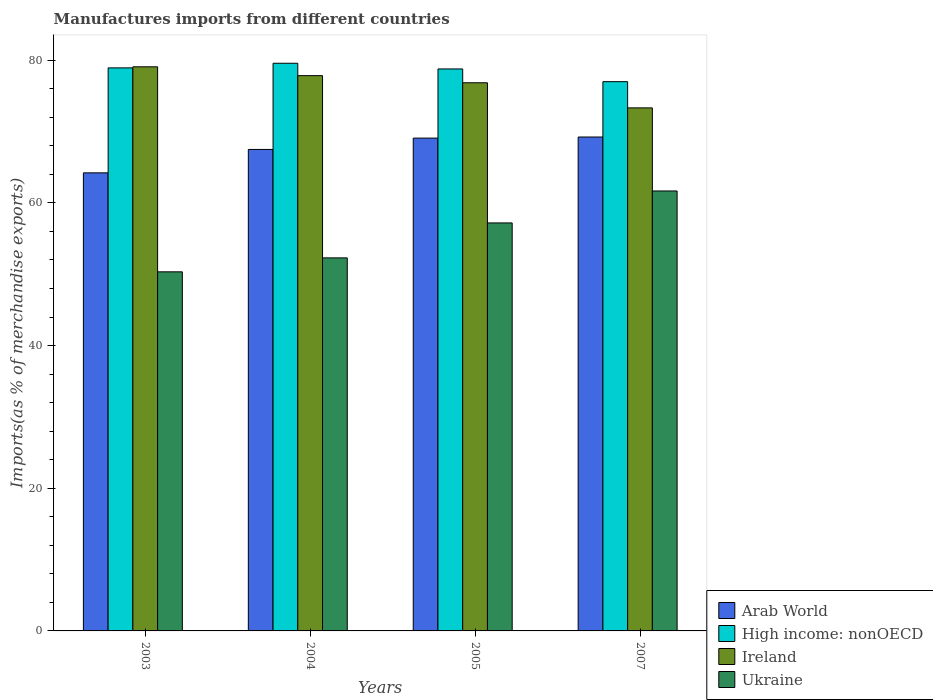How many groups of bars are there?
Your response must be concise. 4. How many bars are there on the 1st tick from the right?
Your response must be concise. 4. What is the label of the 4th group of bars from the left?
Offer a very short reply. 2007. What is the percentage of imports to different countries in High income: nonOECD in 2005?
Keep it short and to the point. 78.78. Across all years, what is the maximum percentage of imports to different countries in Ireland?
Your answer should be compact. 79.08. Across all years, what is the minimum percentage of imports to different countries in Ukraine?
Give a very brief answer. 50.34. What is the total percentage of imports to different countries in Ireland in the graph?
Offer a very short reply. 307.09. What is the difference between the percentage of imports to different countries in High income: nonOECD in 2003 and that in 2005?
Your answer should be compact. 0.15. What is the difference between the percentage of imports to different countries in Ukraine in 2005 and the percentage of imports to different countries in Ireland in 2003?
Provide a short and direct response. -21.89. What is the average percentage of imports to different countries in Ukraine per year?
Your answer should be very brief. 55.38. In the year 2004, what is the difference between the percentage of imports to different countries in Ukraine and percentage of imports to different countries in Ireland?
Offer a terse response. -25.55. In how many years, is the percentage of imports to different countries in Arab World greater than 52 %?
Make the answer very short. 4. What is the ratio of the percentage of imports to different countries in Arab World in 2003 to that in 2007?
Offer a terse response. 0.93. Is the percentage of imports to different countries in Ukraine in 2003 less than that in 2005?
Offer a terse response. Yes. What is the difference between the highest and the second highest percentage of imports to different countries in Arab World?
Your response must be concise. 0.15. What is the difference between the highest and the lowest percentage of imports to different countries in Arab World?
Ensure brevity in your answer.  5.03. In how many years, is the percentage of imports to different countries in Ireland greater than the average percentage of imports to different countries in Ireland taken over all years?
Give a very brief answer. 3. Is it the case that in every year, the sum of the percentage of imports to different countries in Ireland and percentage of imports to different countries in Arab World is greater than the sum of percentage of imports to different countries in Ukraine and percentage of imports to different countries in High income: nonOECD?
Provide a succinct answer. No. What does the 4th bar from the left in 2003 represents?
Give a very brief answer. Ukraine. What does the 1st bar from the right in 2003 represents?
Your response must be concise. Ukraine. Is it the case that in every year, the sum of the percentage of imports to different countries in High income: nonOECD and percentage of imports to different countries in Ireland is greater than the percentage of imports to different countries in Arab World?
Offer a terse response. Yes. How many bars are there?
Give a very brief answer. 16. Are all the bars in the graph horizontal?
Ensure brevity in your answer.  No. How many years are there in the graph?
Your answer should be very brief. 4. Where does the legend appear in the graph?
Your response must be concise. Bottom right. How many legend labels are there?
Provide a succinct answer. 4. What is the title of the graph?
Provide a succinct answer. Manufactures imports from different countries. What is the label or title of the Y-axis?
Offer a terse response. Imports(as % of merchandise exports). What is the Imports(as % of merchandise exports) of Arab World in 2003?
Your response must be concise. 64.22. What is the Imports(as % of merchandise exports) of High income: nonOECD in 2003?
Offer a very short reply. 78.93. What is the Imports(as % of merchandise exports) of Ireland in 2003?
Give a very brief answer. 79.08. What is the Imports(as % of merchandise exports) of Ukraine in 2003?
Your answer should be compact. 50.34. What is the Imports(as % of merchandise exports) of Arab World in 2004?
Offer a terse response. 67.5. What is the Imports(as % of merchandise exports) in High income: nonOECD in 2004?
Offer a very short reply. 79.58. What is the Imports(as % of merchandise exports) in Ireland in 2004?
Give a very brief answer. 77.84. What is the Imports(as % of merchandise exports) in Ukraine in 2004?
Provide a succinct answer. 52.3. What is the Imports(as % of merchandise exports) of Arab World in 2005?
Provide a short and direct response. 69.09. What is the Imports(as % of merchandise exports) of High income: nonOECD in 2005?
Keep it short and to the point. 78.78. What is the Imports(as % of merchandise exports) of Ireland in 2005?
Provide a succinct answer. 76.84. What is the Imports(as % of merchandise exports) of Ukraine in 2005?
Keep it short and to the point. 57.19. What is the Imports(as % of merchandise exports) in Arab World in 2007?
Keep it short and to the point. 69.24. What is the Imports(as % of merchandise exports) in High income: nonOECD in 2007?
Offer a very short reply. 77. What is the Imports(as % of merchandise exports) in Ireland in 2007?
Keep it short and to the point. 73.32. What is the Imports(as % of merchandise exports) in Ukraine in 2007?
Provide a short and direct response. 61.68. Across all years, what is the maximum Imports(as % of merchandise exports) in Arab World?
Your answer should be compact. 69.24. Across all years, what is the maximum Imports(as % of merchandise exports) in High income: nonOECD?
Give a very brief answer. 79.58. Across all years, what is the maximum Imports(as % of merchandise exports) of Ireland?
Your response must be concise. 79.08. Across all years, what is the maximum Imports(as % of merchandise exports) in Ukraine?
Give a very brief answer. 61.68. Across all years, what is the minimum Imports(as % of merchandise exports) of Arab World?
Keep it short and to the point. 64.22. Across all years, what is the minimum Imports(as % of merchandise exports) of High income: nonOECD?
Ensure brevity in your answer.  77. Across all years, what is the minimum Imports(as % of merchandise exports) of Ireland?
Offer a very short reply. 73.32. Across all years, what is the minimum Imports(as % of merchandise exports) of Ukraine?
Give a very brief answer. 50.34. What is the total Imports(as % of merchandise exports) of Arab World in the graph?
Keep it short and to the point. 270.04. What is the total Imports(as % of merchandise exports) in High income: nonOECD in the graph?
Your answer should be very brief. 314.29. What is the total Imports(as % of merchandise exports) of Ireland in the graph?
Offer a very short reply. 307.09. What is the total Imports(as % of merchandise exports) of Ukraine in the graph?
Make the answer very short. 221.51. What is the difference between the Imports(as % of merchandise exports) in Arab World in 2003 and that in 2004?
Your answer should be compact. -3.28. What is the difference between the Imports(as % of merchandise exports) of High income: nonOECD in 2003 and that in 2004?
Your answer should be compact. -0.65. What is the difference between the Imports(as % of merchandise exports) in Ireland in 2003 and that in 2004?
Keep it short and to the point. 1.24. What is the difference between the Imports(as % of merchandise exports) in Ukraine in 2003 and that in 2004?
Keep it short and to the point. -1.96. What is the difference between the Imports(as % of merchandise exports) in Arab World in 2003 and that in 2005?
Your answer should be compact. -4.87. What is the difference between the Imports(as % of merchandise exports) in High income: nonOECD in 2003 and that in 2005?
Your answer should be compact. 0.15. What is the difference between the Imports(as % of merchandise exports) in Ireland in 2003 and that in 2005?
Your answer should be compact. 2.24. What is the difference between the Imports(as % of merchandise exports) of Ukraine in 2003 and that in 2005?
Make the answer very short. -6.86. What is the difference between the Imports(as % of merchandise exports) of Arab World in 2003 and that in 2007?
Ensure brevity in your answer.  -5.03. What is the difference between the Imports(as % of merchandise exports) in High income: nonOECD in 2003 and that in 2007?
Your answer should be compact. 1.93. What is the difference between the Imports(as % of merchandise exports) in Ireland in 2003 and that in 2007?
Your answer should be compact. 5.76. What is the difference between the Imports(as % of merchandise exports) of Ukraine in 2003 and that in 2007?
Ensure brevity in your answer.  -11.34. What is the difference between the Imports(as % of merchandise exports) of Arab World in 2004 and that in 2005?
Your answer should be compact. -1.59. What is the difference between the Imports(as % of merchandise exports) in High income: nonOECD in 2004 and that in 2005?
Ensure brevity in your answer.  0.8. What is the difference between the Imports(as % of merchandise exports) in Ireland in 2004 and that in 2005?
Keep it short and to the point. 1. What is the difference between the Imports(as % of merchandise exports) in Ukraine in 2004 and that in 2005?
Ensure brevity in your answer.  -4.9. What is the difference between the Imports(as % of merchandise exports) in Arab World in 2004 and that in 2007?
Offer a very short reply. -1.74. What is the difference between the Imports(as % of merchandise exports) in High income: nonOECD in 2004 and that in 2007?
Provide a short and direct response. 2.58. What is the difference between the Imports(as % of merchandise exports) of Ireland in 2004 and that in 2007?
Offer a very short reply. 4.52. What is the difference between the Imports(as % of merchandise exports) in Ukraine in 2004 and that in 2007?
Ensure brevity in your answer.  -9.38. What is the difference between the Imports(as % of merchandise exports) in Arab World in 2005 and that in 2007?
Offer a terse response. -0.15. What is the difference between the Imports(as % of merchandise exports) in High income: nonOECD in 2005 and that in 2007?
Your response must be concise. 1.78. What is the difference between the Imports(as % of merchandise exports) in Ireland in 2005 and that in 2007?
Give a very brief answer. 3.52. What is the difference between the Imports(as % of merchandise exports) of Ukraine in 2005 and that in 2007?
Offer a terse response. -4.48. What is the difference between the Imports(as % of merchandise exports) in Arab World in 2003 and the Imports(as % of merchandise exports) in High income: nonOECD in 2004?
Your answer should be very brief. -15.36. What is the difference between the Imports(as % of merchandise exports) in Arab World in 2003 and the Imports(as % of merchandise exports) in Ireland in 2004?
Provide a succinct answer. -13.63. What is the difference between the Imports(as % of merchandise exports) of Arab World in 2003 and the Imports(as % of merchandise exports) of Ukraine in 2004?
Give a very brief answer. 11.92. What is the difference between the Imports(as % of merchandise exports) in High income: nonOECD in 2003 and the Imports(as % of merchandise exports) in Ireland in 2004?
Your answer should be very brief. 1.09. What is the difference between the Imports(as % of merchandise exports) of High income: nonOECD in 2003 and the Imports(as % of merchandise exports) of Ukraine in 2004?
Make the answer very short. 26.64. What is the difference between the Imports(as % of merchandise exports) of Ireland in 2003 and the Imports(as % of merchandise exports) of Ukraine in 2004?
Ensure brevity in your answer.  26.79. What is the difference between the Imports(as % of merchandise exports) in Arab World in 2003 and the Imports(as % of merchandise exports) in High income: nonOECD in 2005?
Your response must be concise. -14.57. What is the difference between the Imports(as % of merchandise exports) in Arab World in 2003 and the Imports(as % of merchandise exports) in Ireland in 2005?
Your answer should be compact. -12.63. What is the difference between the Imports(as % of merchandise exports) of Arab World in 2003 and the Imports(as % of merchandise exports) of Ukraine in 2005?
Your answer should be very brief. 7.02. What is the difference between the Imports(as % of merchandise exports) of High income: nonOECD in 2003 and the Imports(as % of merchandise exports) of Ireland in 2005?
Offer a very short reply. 2.09. What is the difference between the Imports(as % of merchandise exports) in High income: nonOECD in 2003 and the Imports(as % of merchandise exports) in Ukraine in 2005?
Give a very brief answer. 21.74. What is the difference between the Imports(as % of merchandise exports) in Ireland in 2003 and the Imports(as % of merchandise exports) in Ukraine in 2005?
Keep it short and to the point. 21.89. What is the difference between the Imports(as % of merchandise exports) of Arab World in 2003 and the Imports(as % of merchandise exports) of High income: nonOECD in 2007?
Give a very brief answer. -12.78. What is the difference between the Imports(as % of merchandise exports) of Arab World in 2003 and the Imports(as % of merchandise exports) of Ireland in 2007?
Your answer should be compact. -9.11. What is the difference between the Imports(as % of merchandise exports) in Arab World in 2003 and the Imports(as % of merchandise exports) in Ukraine in 2007?
Your answer should be very brief. 2.54. What is the difference between the Imports(as % of merchandise exports) in High income: nonOECD in 2003 and the Imports(as % of merchandise exports) in Ireland in 2007?
Provide a succinct answer. 5.61. What is the difference between the Imports(as % of merchandise exports) in High income: nonOECD in 2003 and the Imports(as % of merchandise exports) in Ukraine in 2007?
Offer a terse response. 17.26. What is the difference between the Imports(as % of merchandise exports) in Ireland in 2003 and the Imports(as % of merchandise exports) in Ukraine in 2007?
Your response must be concise. 17.41. What is the difference between the Imports(as % of merchandise exports) of Arab World in 2004 and the Imports(as % of merchandise exports) of High income: nonOECD in 2005?
Keep it short and to the point. -11.28. What is the difference between the Imports(as % of merchandise exports) of Arab World in 2004 and the Imports(as % of merchandise exports) of Ireland in 2005?
Give a very brief answer. -9.34. What is the difference between the Imports(as % of merchandise exports) of Arab World in 2004 and the Imports(as % of merchandise exports) of Ukraine in 2005?
Your answer should be compact. 10.3. What is the difference between the Imports(as % of merchandise exports) of High income: nonOECD in 2004 and the Imports(as % of merchandise exports) of Ireland in 2005?
Make the answer very short. 2.74. What is the difference between the Imports(as % of merchandise exports) of High income: nonOECD in 2004 and the Imports(as % of merchandise exports) of Ukraine in 2005?
Ensure brevity in your answer.  22.38. What is the difference between the Imports(as % of merchandise exports) of Ireland in 2004 and the Imports(as % of merchandise exports) of Ukraine in 2005?
Provide a succinct answer. 20.65. What is the difference between the Imports(as % of merchandise exports) of Arab World in 2004 and the Imports(as % of merchandise exports) of High income: nonOECD in 2007?
Offer a terse response. -9.5. What is the difference between the Imports(as % of merchandise exports) in Arab World in 2004 and the Imports(as % of merchandise exports) in Ireland in 2007?
Your answer should be very brief. -5.83. What is the difference between the Imports(as % of merchandise exports) in Arab World in 2004 and the Imports(as % of merchandise exports) in Ukraine in 2007?
Offer a terse response. 5.82. What is the difference between the Imports(as % of merchandise exports) in High income: nonOECD in 2004 and the Imports(as % of merchandise exports) in Ireland in 2007?
Offer a very short reply. 6.26. What is the difference between the Imports(as % of merchandise exports) of High income: nonOECD in 2004 and the Imports(as % of merchandise exports) of Ukraine in 2007?
Keep it short and to the point. 17.9. What is the difference between the Imports(as % of merchandise exports) of Ireland in 2004 and the Imports(as % of merchandise exports) of Ukraine in 2007?
Offer a very short reply. 16.17. What is the difference between the Imports(as % of merchandise exports) of Arab World in 2005 and the Imports(as % of merchandise exports) of High income: nonOECD in 2007?
Offer a terse response. -7.91. What is the difference between the Imports(as % of merchandise exports) of Arab World in 2005 and the Imports(as % of merchandise exports) of Ireland in 2007?
Provide a short and direct response. -4.24. What is the difference between the Imports(as % of merchandise exports) in Arab World in 2005 and the Imports(as % of merchandise exports) in Ukraine in 2007?
Offer a terse response. 7.41. What is the difference between the Imports(as % of merchandise exports) in High income: nonOECD in 2005 and the Imports(as % of merchandise exports) in Ireland in 2007?
Keep it short and to the point. 5.46. What is the difference between the Imports(as % of merchandise exports) in High income: nonOECD in 2005 and the Imports(as % of merchandise exports) in Ukraine in 2007?
Provide a succinct answer. 17.11. What is the difference between the Imports(as % of merchandise exports) in Ireland in 2005 and the Imports(as % of merchandise exports) in Ukraine in 2007?
Offer a very short reply. 15.17. What is the average Imports(as % of merchandise exports) of Arab World per year?
Your answer should be compact. 67.51. What is the average Imports(as % of merchandise exports) of High income: nonOECD per year?
Your answer should be very brief. 78.57. What is the average Imports(as % of merchandise exports) in Ireland per year?
Ensure brevity in your answer.  76.77. What is the average Imports(as % of merchandise exports) of Ukraine per year?
Offer a very short reply. 55.38. In the year 2003, what is the difference between the Imports(as % of merchandise exports) in Arab World and Imports(as % of merchandise exports) in High income: nonOECD?
Your answer should be very brief. -14.72. In the year 2003, what is the difference between the Imports(as % of merchandise exports) in Arab World and Imports(as % of merchandise exports) in Ireland?
Keep it short and to the point. -14.87. In the year 2003, what is the difference between the Imports(as % of merchandise exports) in Arab World and Imports(as % of merchandise exports) in Ukraine?
Give a very brief answer. 13.88. In the year 2003, what is the difference between the Imports(as % of merchandise exports) of High income: nonOECD and Imports(as % of merchandise exports) of Ireland?
Make the answer very short. -0.15. In the year 2003, what is the difference between the Imports(as % of merchandise exports) of High income: nonOECD and Imports(as % of merchandise exports) of Ukraine?
Provide a short and direct response. 28.59. In the year 2003, what is the difference between the Imports(as % of merchandise exports) of Ireland and Imports(as % of merchandise exports) of Ukraine?
Make the answer very short. 28.74. In the year 2004, what is the difference between the Imports(as % of merchandise exports) in Arab World and Imports(as % of merchandise exports) in High income: nonOECD?
Keep it short and to the point. -12.08. In the year 2004, what is the difference between the Imports(as % of merchandise exports) in Arab World and Imports(as % of merchandise exports) in Ireland?
Offer a very short reply. -10.35. In the year 2004, what is the difference between the Imports(as % of merchandise exports) in Arab World and Imports(as % of merchandise exports) in Ukraine?
Keep it short and to the point. 15.2. In the year 2004, what is the difference between the Imports(as % of merchandise exports) in High income: nonOECD and Imports(as % of merchandise exports) in Ireland?
Offer a very short reply. 1.74. In the year 2004, what is the difference between the Imports(as % of merchandise exports) of High income: nonOECD and Imports(as % of merchandise exports) of Ukraine?
Your response must be concise. 27.28. In the year 2004, what is the difference between the Imports(as % of merchandise exports) in Ireland and Imports(as % of merchandise exports) in Ukraine?
Provide a short and direct response. 25.55. In the year 2005, what is the difference between the Imports(as % of merchandise exports) of Arab World and Imports(as % of merchandise exports) of High income: nonOECD?
Your response must be concise. -9.69. In the year 2005, what is the difference between the Imports(as % of merchandise exports) in Arab World and Imports(as % of merchandise exports) in Ireland?
Your response must be concise. -7.75. In the year 2005, what is the difference between the Imports(as % of merchandise exports) in Arab World and Imports(as % of merchandise exports) in Ukraine?
Provide a succinct answer. 11.89. In the year 2005, what is the difference between the Imports(as % of merchandise exports) of High income: nonOECD and Imports(as % of merchandise exports) of Ireland?
Your answer should be very brief. 1.94. In the year 2005, what is the difference between the Imports(as % of merchandise exports) in High income: nonOECD and Imports(as % of merchandise exports) in Ukraine?
Your answer should be very brief. 21.59. In the year 2005, what is the difference between the Imports(as % of merchandise exports) in Ireland and Imports(as % of merchandise exports) in Ukraine?
Your answer should be very brief. 19.65. In the year 2007, what is the difference between the Imports(as % of merchandise exports) of Arab World and Imports(as % of merchandise exports) of High income: nonOECD?
Your answer should be very brief. -7.76. In the year 2007, what is the difference between the Imports(as % of merchandise exports) of Arab World and Imports(as % of merchandise exports) of Ireland?
Your response must be concise. -4.08. In the year 2007, what is the difference between the Imports(as % of merchandise exports) of Arab World and Imports(as % of merchandise exports) of Ukraine?
Your answer should be compact. 7.57. In the year 2007, what is the difference between the Imports(as % of merchandise exports) in High income: nonOECD and Imports(as % of merchandise exports) in Ireland?
Offer a terse response. 3.68. In the year 2007, what is the difference between the Imports(as % of merchandise exports) in High income: nonOECD and Imports(as % of merchandise exports) in Ukraine?
Your answer should be compact. 15.32. In the year 2007, what is the difference between the Imports(as % of merchandise exports) of Ireland and Imports(as % of merchandise exports) of Ukraine?
Give a very brief answer. 11.65. What is the ratio of the Imports(as % of merchandise exports) of Arab World in 2003 to that in 2004?
Offer a terse response. 0.95. What is the ratio of the Imports(as % of merchandise exports) of Ireland in 2003 to that in 2004?
Offer a terse response. 1.02. What is the ratio of the Imports(as % of merchandise exports) of Ukraine in 2003 to that in 2004?
Provide a short and direct response. 0.96. What is the ratio of the Imports(as % of merchandise exports) in Arab World in 2003 to that in 2005?
Ensure brevity in your answer.  0.93. What is the ratio of the Imports(as % of merchandise exports) of Ireland in 2003 to that in 2005?
Ensure brevity in your answer.  1.03. What is the ratio of the Imports(as % of merchandise exports) in Ukraine in 2003 to that in 2005?
Provide a succinct answer. 0.88. What is the ratio of the Imports(as % of merchandise exports) in Arab World in 2003 to that in 2007?
Offer a very short reply. 0.93. What is the ratio of the Imports(as % of merchandise exports) of High income: nonOECD in 2003 to that in 2007?
Your answer should be compact. 1.03. What is the ratio of the Imports(as % of merchandise exports) in Ireland in 2003 to that in 2007?
Your response must be concise. 1.08. What is the ratio of the Imports(as % of merchandise exports) of Ukraine in 2003 to that in 2007?
Offer a very short reply. 0.82. What is the ratio of the Imports(as % of merchandise exports) in Ukraine in 2004 to that in 2005?
Make the answer very short. 0.91. What is the ratio of the Imports(as % of merchandise exports) in Arab World in 2004 to that in 2007?
Keep it short and to the point. 0.97. What is the ratio of the Imports(as % of merchandise exports) in High income: nonOECD in 2004 to that in 2007?
Ensure brevity in your answer.  1.03. What is the ratio of the Imports(as % of merchandise exports) in Ireland in 2004 to that in 2007?
Your answer should be compact. 1.06. What is the ratio of the Imports(as % of merchandise exports) in Ukraine in 2004 to that in 2007?
Offer a terse response. 0.85. What is the ratio of the Imports(as % of merchandise exports) of Arab World in 2005 to that in 2007?
Provide a short and direct response. 1. What is the ratio of the Imports(as % of merchandise exports) in High income: nonOECD in 2005 to that in 2007?
Make the answer very short. 1.02. What is the ratio of the Imports(as % of merchandise exports) of Ireland in 2005 to that in 2007?
Your answer should be compact. 1.05. What is the ratio of the Imports(as % of merchandise exports) in Ukraine in 2005 to that in 2007?
Ensure brevity in your answer.  0.93. What is the difference between the highest and the second highest Imports(as % of merchandise exports) in Arab World?
Offer a very short reply. 0.15. What is the difference between the highest and the second highest Imports(as % of merchandise exports) of High income: nonOECD?
Offer a terse response. 0.65. What is the difference between the highest and the second highest Imports(as % of merchandise exports) of Ireland?
Offer a very short reply. 1.24. What is the difference between the highest and the second highest Imports(as % of merchandise exports) of Ukraine?
Your answer should be compact. 4.48. What is the difference between the highest and the lowest Imports(as % of merchandise exports) of Arab World?
Your response must be concise. 5.03. What is the difference between the highest and the lowest Imports(as % of merchandise exports) in High income: nonOECD?
Offer a terse response. 2.58. What is the difference between the highest and the lowest Imports(as % of merchandise exports) in Ireland?
Provide a short and direct response. 5.76. What is the difference between the highest and the lowest Imports(as % of merchandise exports) in Ukraine?
Your response must be concise. 11.34. 